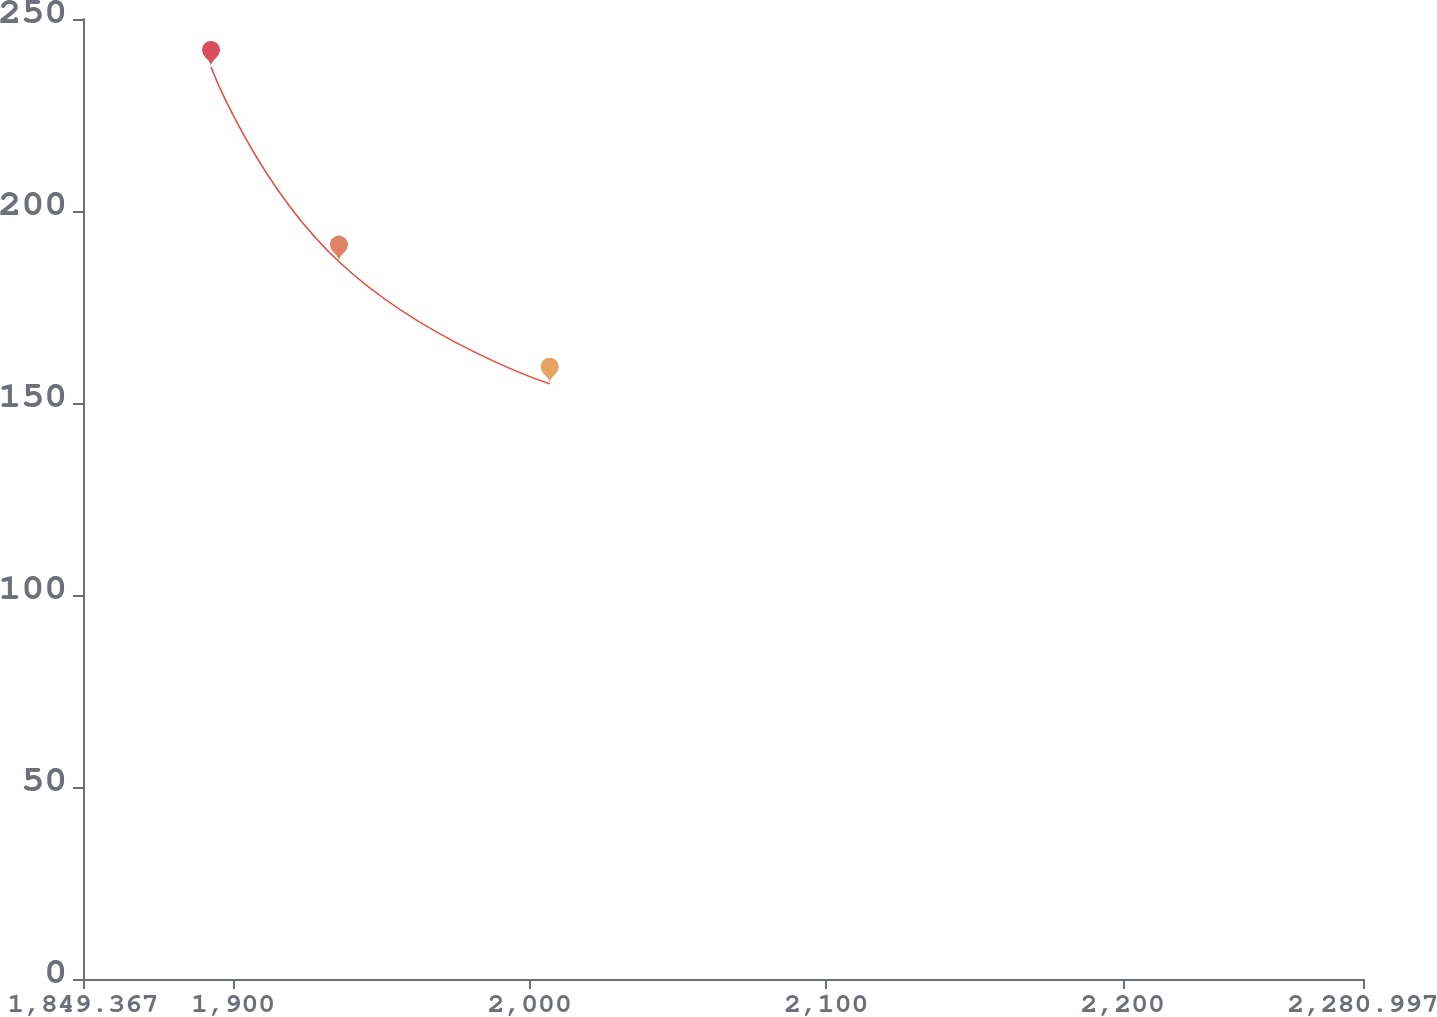Convert chart. <chart><loc_0><loc_0><loc_500><loc_500><line_chart><ecel><fcel>$ 218.1<nl><fcel>1892.53<fcel>237.48<nl><fcel>1935.69<fcel>186.78<nl><fcel>2006.74<fcel>154.99<nl><fcel>2324.16<fcel>5.18<nl></chart> 